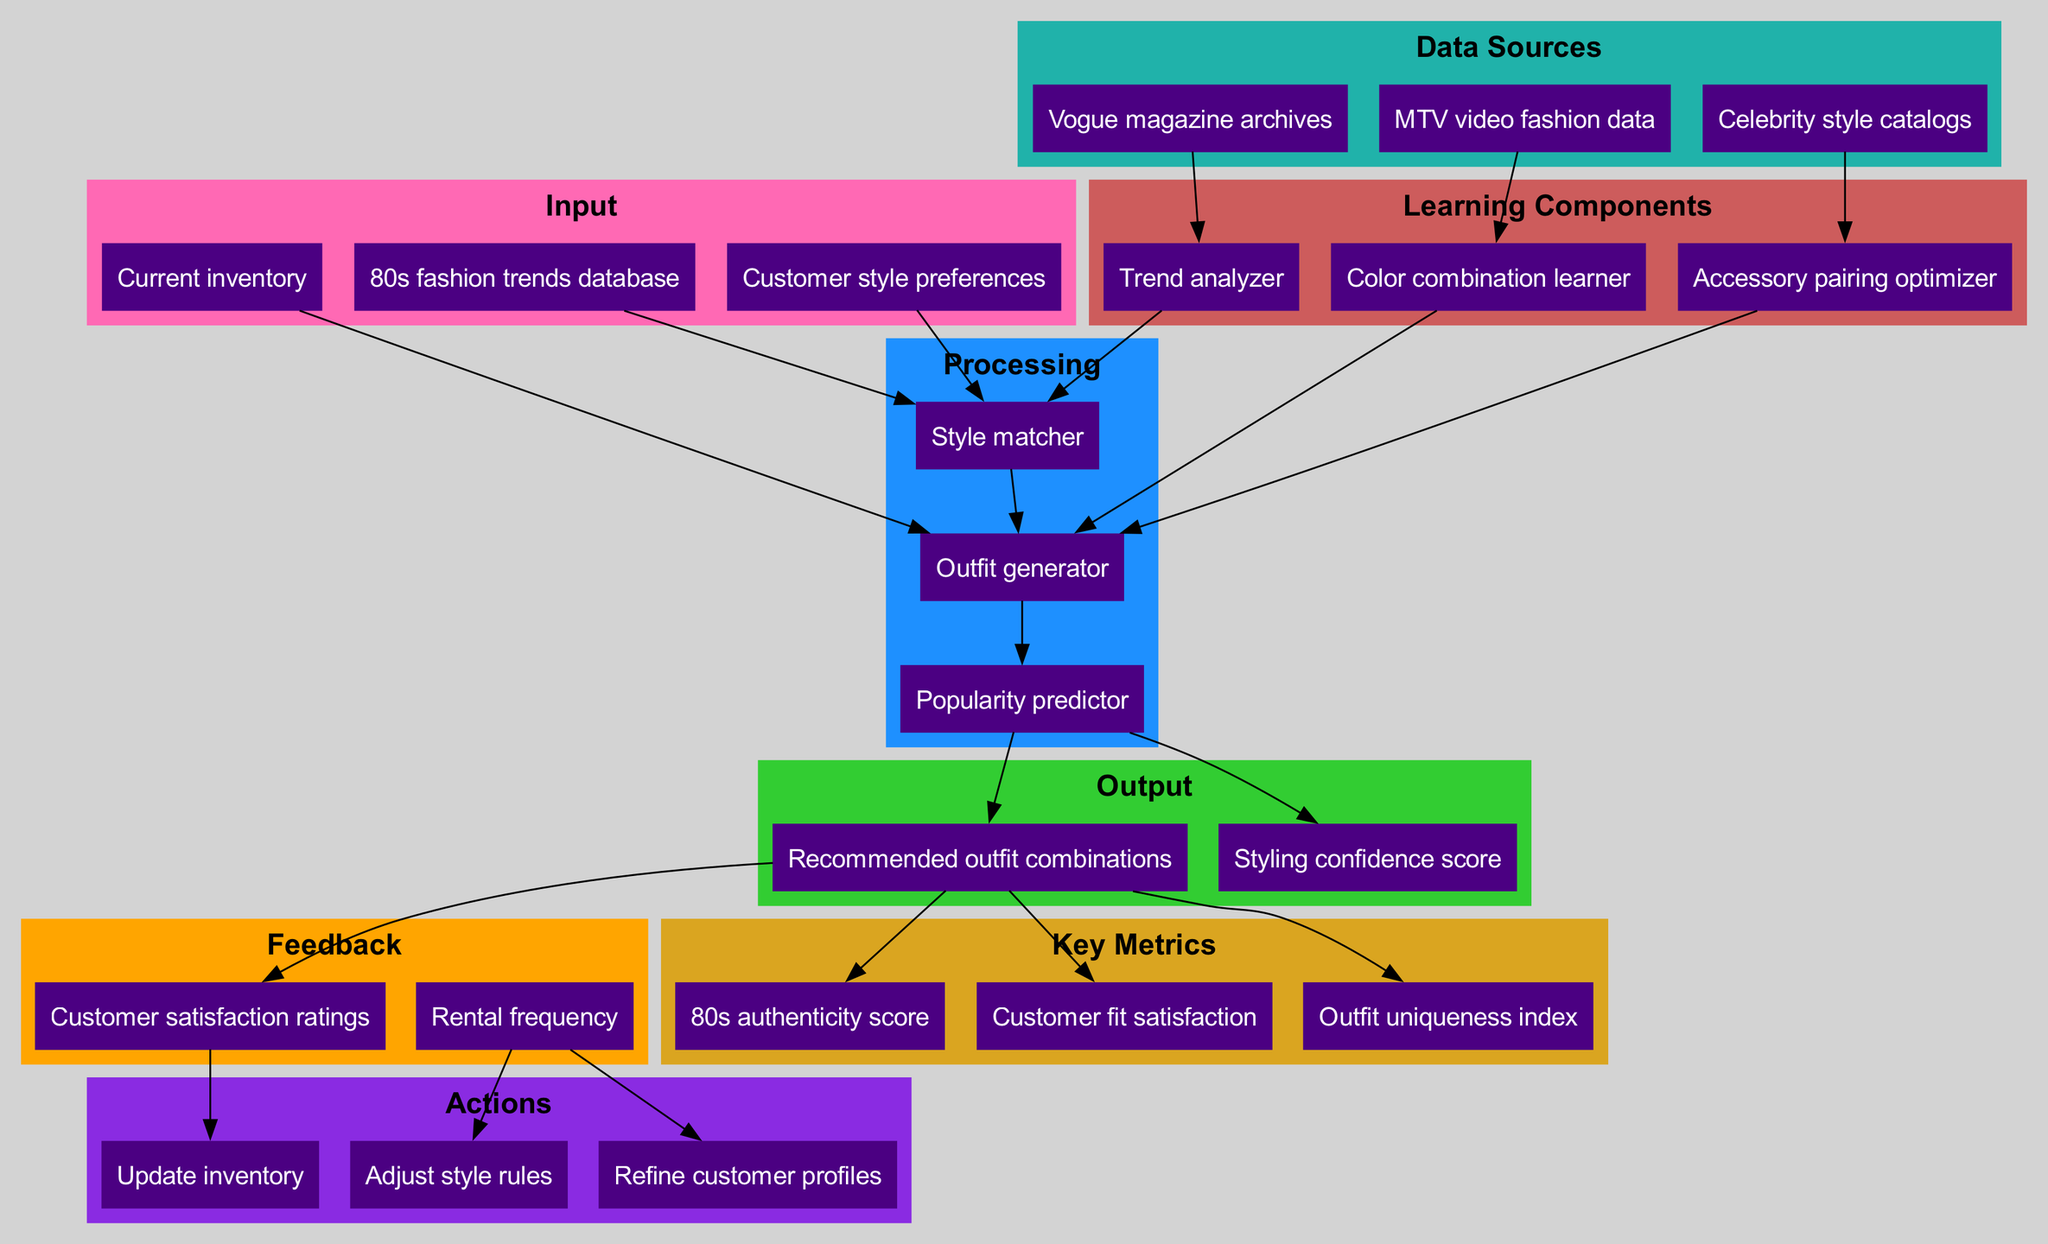How many input nodes are there in the diagram? The diagram lists three distinct nodes under the input section: "Customer style preferences," "80s fashion trends database," and "Current inventory." Therefore, counting these gives us the total number of input nodes.
Answer: 3 What does the "Outfit generator" node receive as input? The "Outfit generator" receives input from two nodes: "Current inventory" and "Style matcher." This is evident by the edges connecting these nodes to the "Outfit generator" node.
Answer: Current inventory and Style matcher Which output node is directly influenced by the "Popularity predictor"? The "Recommended outfit combinations" and "Styling confidence score" nodes are directly connected to the "Popularity predictor." This is shown by the direct edges leading to these output nodes from the "Popularity predictor."
Answer: Recommended outfit combinations and Styling confidence score What action do customer satisfaction ratings influence? Customer satisfaction ratings influence the action "Update inventory." This can be determined by the edge that connects "Customer satisfaction ratings" to "Update inventory," indicating that customer feedback leads to inventory updates.
Answer: Update inventory How many learning components are present in the diagram? There are three learning components listed in the diagram: "Trend analyzer," "Color combination learner," and "Accessory pairing optimizer." Counting these provides the answer.
Answer: 3 Which data source feeds the "Trend analyzer"? The "Vogue magazine archives" data source is shown to directly feed into the "Trend analyzer," as indicated by the connecting edge from "Vogue magazine archives" to "Trend analyzer."
Answer: Vogue magazine archives Which key metric is related to outfit combinations? The key metrics that relate to outfit combinations include "80s authenticity score," "Customer fit satisfaction," and "Outfit uniqueness index." All these metrics are tied to the output "Recommended outfit combinations."
Answer: 80s authenticity score, Customer fit satisfaction, and Outfit uniqueness index What happens when there is high "Rental frequency"? High "Rental frequency" leads to two actions: "Adjust style rules" and "Refine customer profiles." This is noted by the edges leading from "Rental frequency" to these two action nodes.
Answer: Adjust style rules and Refine customer profiles How does the "Color combination learner" contribute to the system? The "Color combination learner" contributes by feeding into the "Outfit generator." This is indicated by the direct edge connecting "Color combination learner" to "Outfit generator," showing it plays a role in determining outfit options based on color combinations.
Answer: Outfit generator 